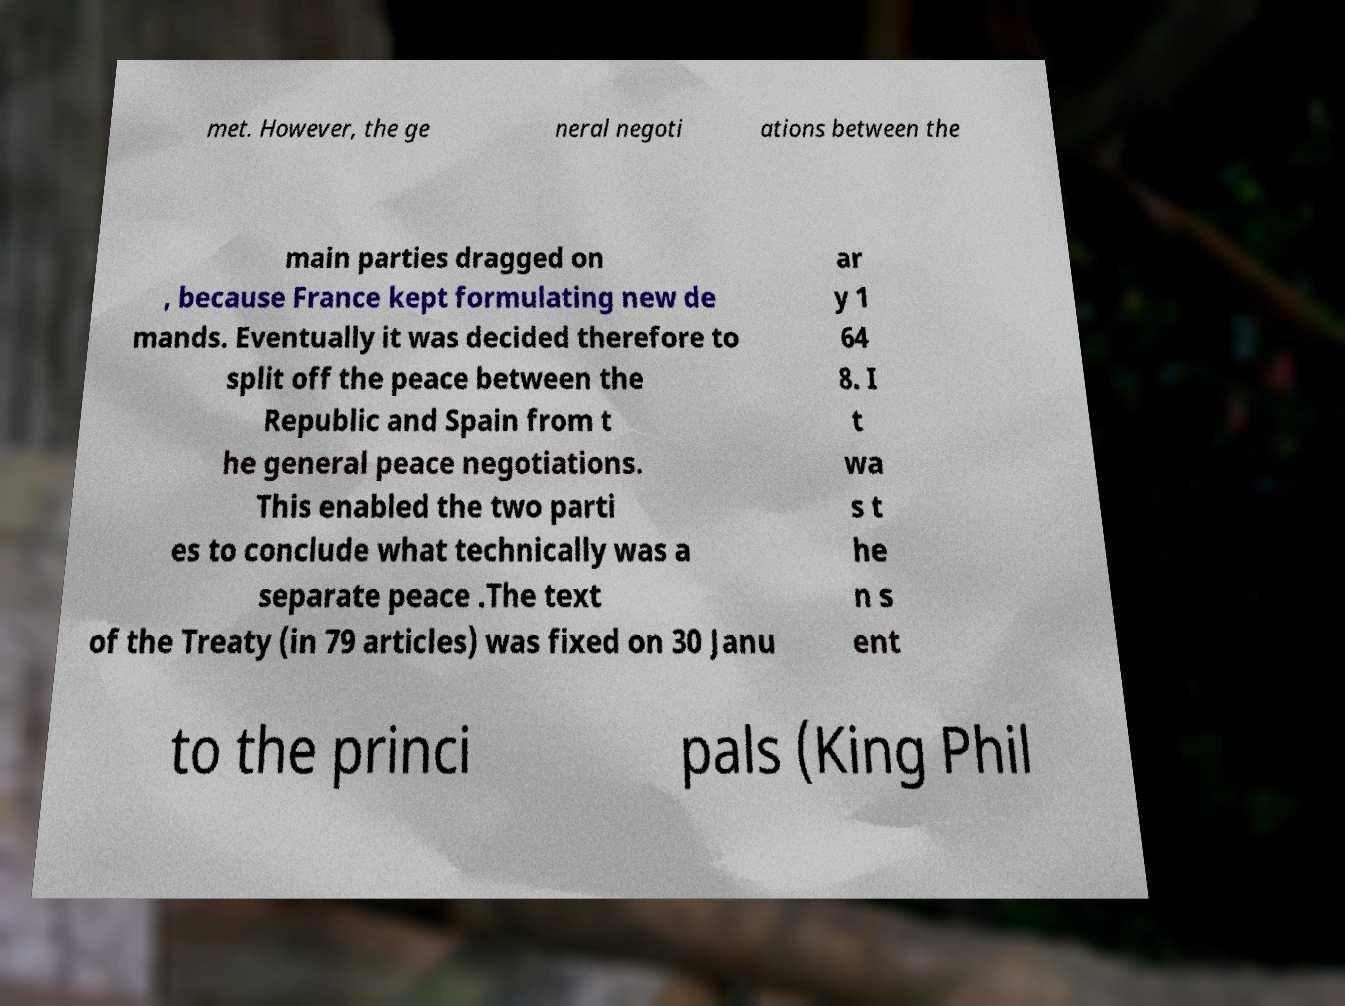Can you accurately transcribe the text from the provided image for me? met. However, the ge neral negoti ations between the main parties dragged on , because France kept formulating new de mands. Eventually it was decided therefore to split off the peace between the Republic and Spain from t he general peace negotiations. This enabled the two parti es to conclude what technically was a separate peace .The text of the Treaty (in 79 articles) was fixed on 30 Janu ar y 1 64 8. I t wa s t he n s ent to the princi pals (King Phil 